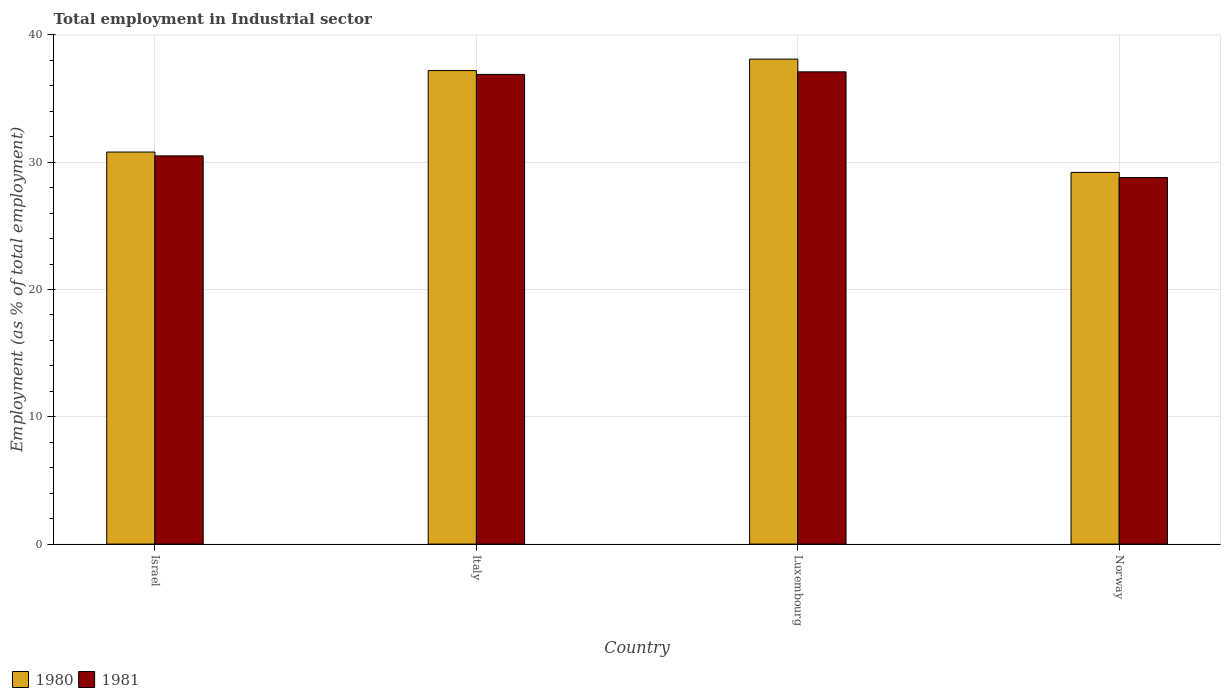How many groups of bars are there?
Give a very brief answer. 4. What is the label of the 1st group of bars from the left?
Your answer should be compact. Israel. What is the employment in industrial sector in 1981 in Italy?
Offer a very short reply. 36.9. Across all countries, what is the maximum employment in industrial sector in 1981?
Offer a very short reply. 37.1. Across all countries, what is the minimum employment in industrial sector in 1980?
Make the answer very short. 29.2. In which country was the employment in industrial sector in 1981 maximum?
Your answer should be very brief. Luxembourg. In which country was the employment in industrial sector in 1981 minimum?
Your answer should be very brief. Norway. What is the total employment in industrial sector in 1980 in the graph?
Your response must be concise. 135.3. What is the difference between the employment in industrial sector in 1981 in Israel and that in Norway?
Your response must be concise. 1.7. What is the difference between the employment in industrial sector in 1981 in Norway and the employment in industrial sector in 1980 in Italy?
Ensure brevity in your answer.  -8.4. What is the average employment in industrial sector in 1981 per country?
Provide a succinct answer. 33.32. What is the difference between the employment in industrial sector of/in 1980 and employment in industrial sector of/in 1981 in Norway?
Your response must be concise. 0.4. What is the ratio of the employment in industrial sector in 1980 in Israel to that in Luxembourg?
Provide a short and direct response. 0.81. Is the employment in industrial sector in 1981 in Israel less than that in Luxembourg?
Make the answer very short. Yes. Is the difference between the employment in industrial sector in 1980 in Israel and Luxembourg greater than the difference between the employment in industrial sector in 1981 in Israel and Luxembourg?
Offer a terse response. No. What is the difference between the highest and the second highest employment in industrial sector in 1981?
Offer a very short reply. -0.2. What is the difference between the highest and the lowest employment in industrial sector in 1981?
Provide a succinct answer. 8.3. What does the 2nd bar from the right in Italy represents?
Offer a terse response. 1980. How many bars are there?
Offer a terse response. 8. How many countries are there in the graph?
Your answer should be very brief. 4. Does the graph contain any zero values?
Make the answer very short. No. Does the graph contain grids?
Offer a very short reply. Yes. What is the title of the graph?
Offer a very short reply. Total employment in Industrial sector. Does "1962" appear as one of the legend labels in the graph?
Keep it short and to the point. No. What is the label or title of the Y-axis?
Keep it short and to the point. Employment (as % of total employment). What is the Employment (as % of total employment) in 1980 in Israel?
Offer a very short reply. 30.8. What is the Employment (as % of total employment) of 1981 in Israel?
Keep it short and to the point. 30.5. What is the Employment (as % of total employment) in 1980 in Italy?
Your answer should be very brief. 37.2. What is the Employment (as % of total employment) in 1981 in Italy?
Provide a succinct answer. 36.9. What is the Employment (as % of total employment) of 1980 in Luxembourg?
Ensure brevity in your answer.  38.1. What is the Employment (as % of total employment) in 1981 in Luxembourg?
Offer a very short reply. 37.1. What is the Employment (as % of total employment) in 1980 in Norway?
Make the answer very short. 29.2. What is the Employment (as % of total employment) in 1981 in Norway?
Provide a succinct answer. 28.8. Across all countries, what is the maximum Employment (as % of total employment) in 1980?
Your answer should be very brief. 38.1. Across all countries, what is the maximum Employment (as % of total employment) of 1981?
Provide a succinct answer. 37.1. Across all countries, what is the minimum Employment (as % of total employment) of 1980?
Ensure brevity in your answer.  29.2. Across all countries, what is the minimum Employment (as % of total employment) of 1981?
Keep it short and to the point. 28.8. What is the total Employment (as % of total employment) in 1980 in the graph?
Your answer should be compact. 135.3. What is the total Employment (as % of total employment) of 1981 in the graph?
Offer a very short reply. 133.3. What is the difference between the Employment (as % of total employment) of 1981 in Israel and that in Luxembourg?
Provide a short and direct response. -6.6. What is the difference between the Employment (as % of total employment) in 1981 in Israel and that in Norway?
Keep it short and to the point. 1.7. What is the difference between the Employment (as % of total employment) of 1980 in Italy and that in Luxembourg?
Your answer should be compact. -0.9. What is the difference between the Employment (as % of total employment) in 1980 in Italy and that in Norway?
Your response must be concise. 8. What is the difference between the Employment (as % of total employment) of 1981 in Italy and that in Norway?
Your answer should be very brief. 8.1. What is the difference between the Employment (as % of total employment) of 1980 in Luxembourg and that in Norway?
Keep it short and to the point. 8.9. What is the difference between the Employment (as % of total employment) in 1980 in Israel and the Employment (as % of total employment) in 1981 in Luxembourg?
Offer a very short reply. -6.3. What is the difference between the Employment (as % of total employment) in 1980 in Israel and the Employment (as % of total employment) in 1981 in Norway?
Your response must be concise. 2. What is the difference between the Employment (as % of total employment) in 1980 in Italy and the Employment (as % of total employment) in 1981 in Luxembourg?
Your response must be concise. 0.1. What is the average Employment (as % of total employment) of 1980 per country?
Your answer should be very brief. 33.83. What is the average Employment (as % of total employment) of 1981 per country?
Give a very brief answer. 33.33. What is the difference between the Employment (as % of total employment) of 1980 and Employment (as % of total employment) of 1981 in Israel?
Provide a short and direct response. 0.3. What is the difference between the Employment (as % of total employment) in 1980 and Employment (as % of total employment) in 1981 in Italy?
Offer a very short reply. 0.3. What is the difference between the Employment (as % of total employment) in 1980 and Employment (as % of total employment) in 1981 in Luxembourg?
Your answer should be very brief. 1. What is the difference between the Employment (as % of total employment) in 1980 and Employment (as % of total employment) in 1981 in Norway?
Offer a very short reply. 0.4. What is the ratio of the Employment (as % of total employment) in 1980 in Israel to that in Italy?
Provide a short and direct response. 0.83. What is the ratio of the Employment (as % of total employment) of 1981 in Israel to that in Italy?
Offer a terse response. 0.83. What is the ratio of the Employment (as % of total employment) in 1980 in Israel to that in Luxembourg?
Give a very brief answer. 0.81. What is the ratio of the Employment (as % of total employment) of 1981 in Israel to that in Luxembourg?
Make the answer very short. 0.82. What is the ratio of the Employment (as % of total employment) in 1980 in Israel to that in Norway?
Give a very brief answer. 1.05. What is the ratio of the Employment (as % of total employment) in 1981 in Israel to that in Norway?
Ensure brevity in your answer.  1.06. What is the ratio of the Employment (as % of total employment) of 1980 in Italy to that in Luxembourg?
Ensure brevity in your answer.  0.98. What is the ratio of the Employment (as % of total employment) in 1980 in Italy to that in Norway?
Give a very brief answer. 1.27. What is the ratio of the Employment (as % of total employment) in 1981 in Italy to that in Norway?
Offer a very short reply. 1.28. What is the ratio of the Employment (as % of total employment) in 1980 in Luxembourg to that in Norway?
Your response must be concise. 1.3. What is the ratio of the Employment (as % of total employment) of 1981 in Luxembourg to that in Norway?
Ensure brevity in your answer.  1.29. What is the difference between the highest and the lowest Employment (as % of total employment) of 1980?
Provide a succinct answer. 8.9. What is the difference between the highest and the lowest Employment (as % of total employment) of 1981?
Ensure brevity in your answer.  8.3. 